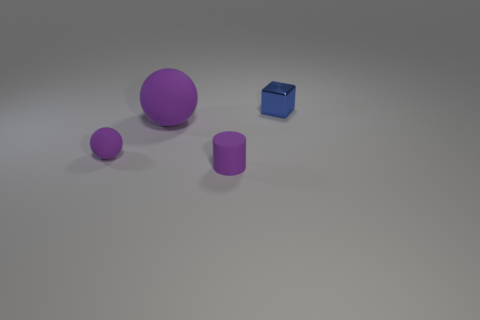Add 1 big green things. How many objects exist? 5 Subtract 0 green blocks. How many objects are left? 4 Subtract all cylinders. How many objects are left? 3 Subtract all big gray metallic cubes. Subtract all tiny metallic cubes. How many objects are left? 3 Add 4 big purple rubber things. How many big purple rubber things are left? 5 Add 1 yellow metallic cylinders. How many yellow metallic cylinders exist? 1 